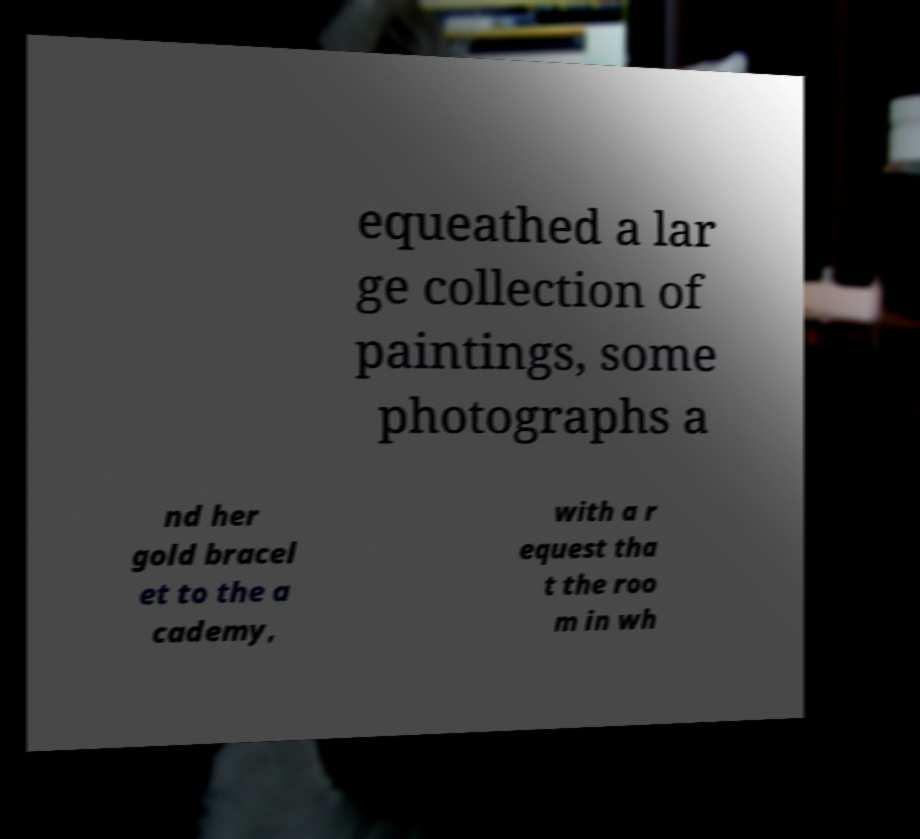For documentation purposes, I need the text within this image transcribed. Could you provide that? equeathed a lar ge collection of paintings, some photographs a nd her gold bracel et to the a cademy, with a r equest tha t the roo m in wh 